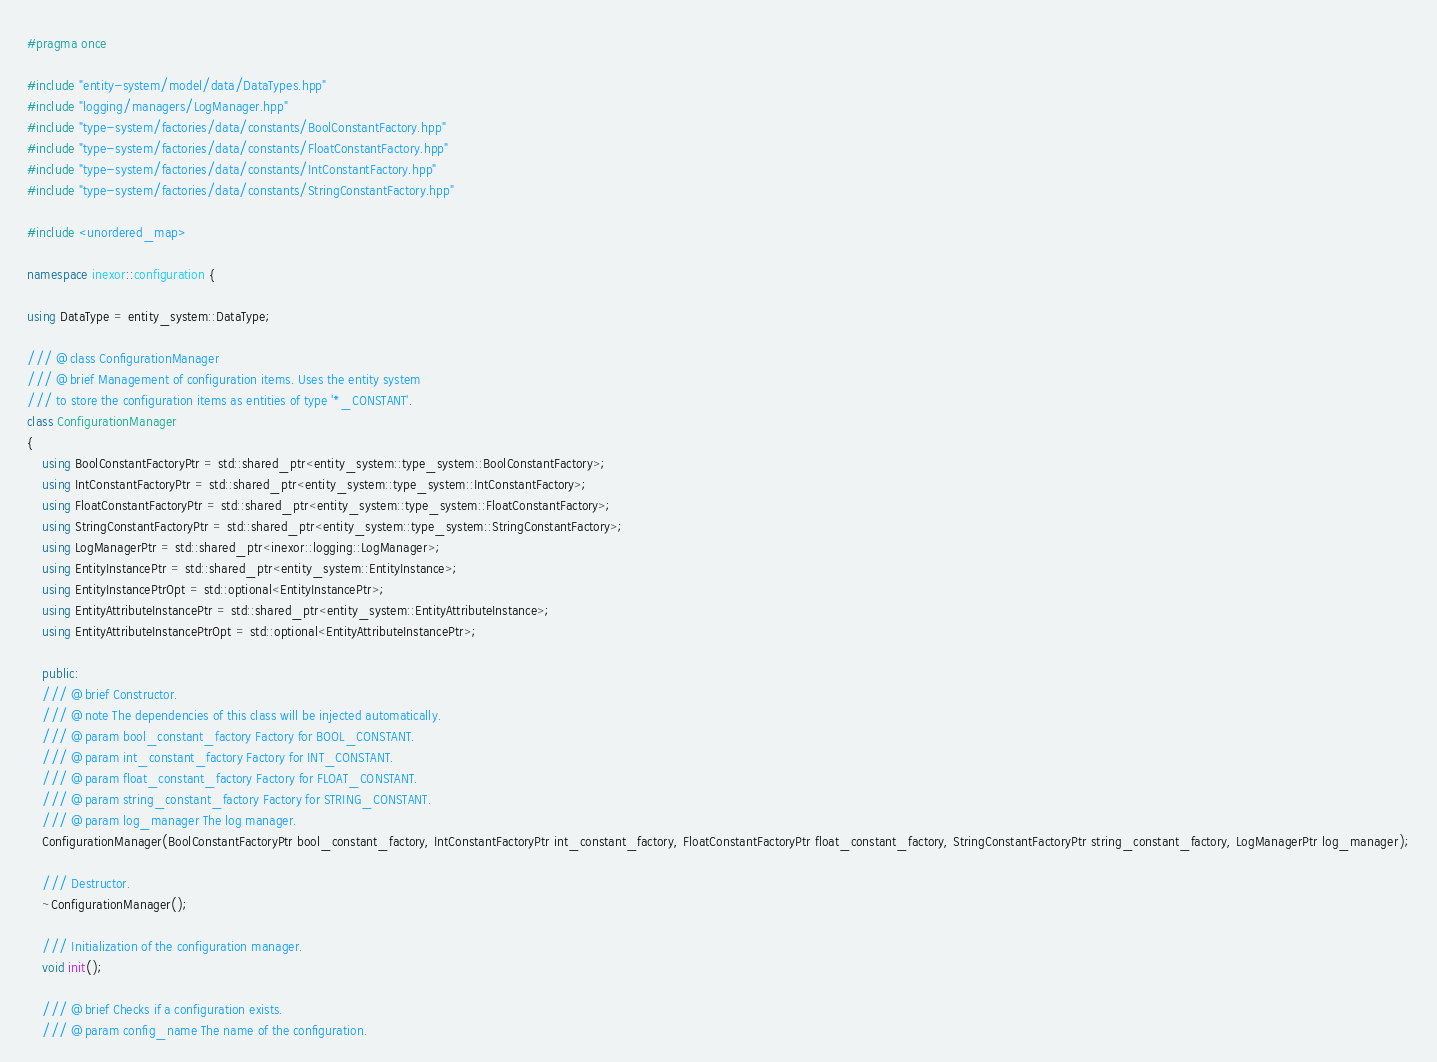<code> <loc_0><loc_0><loc_500><loc_500><_C++_>#pragma once

#include "entity-system/model/data/DataTypes.hpp"
#include "logging/managers/LogManager.hpp"
#include "type-system/factories/data/constants/BoolConstantFactory.hpp"
#include "type-system/factories/data/constants/FloatConstantFactory.hpp"
#include "type-system/factories/data/constants/IntConstantFactory.hpp"
#include "type-system/factories/data/constants/StringConstantFactory.hpp"

#include <unordered_map>

namespace inexor::configuration {

using DataType = entity_system::DataType;

/// @class ConfigurationManager
/// @brief Management of configuration items. Uses the entity system
/// to store the configuration items as entities of type '*_CONSTANT'.
class ConfigurationManager
{
    using BoolConstantFactoryPtr = std::shared_ptr<entity_system::type_system::BoolConstantFactory>;
    using IntConstantFactoryPtr = std::shared_ptr<entity_system::type_system::IntConstantFactory>;
    using FloatConstantFactoryPtr = std::shared_ptr<entity_system::type_system::FloatConstantFactory>;
    using StringConstantFactoryPtr = std::shared_ptr<entity_system::type_system::StringConstantFactory>;
    using LogManagerPtr = std::shared_ptr<inexor::logging::LogManager>;
    using EntityInstancePtr = std::shared_ptr<entity_system::EntityInstance>;
    using EntityInstancePtrOpt = std::optional<EntityInstancePtr>;
    using EntityAttributeInstancePtr = std::shared_ptr<entity_system::EntityAttributeInstance>;
    using EntityAttributeInstancePtrOpt = std::optional<EntityAttributeInstancePtr>;

    public:
    /// @brief Constructor.
    /// @note The dependencies of this class will be injected automatically.
    /// @param bool_constant_factory Factory for BOOL_CONSTANT.
    /// @param int_constant_factory Factory for INT_CONSTANT.
    /// @param float_constant_factory Factory for FLOAT_CONSTANT.
    /// @param string_constant_factory Factory for STRING_CONSTANT.
    /// @param log_manager The log manager.
    ConfigurationManager(BoolConstantFactoryPtr bool_constant_factory, IntConstantFactoryPtr int_constant_factory, FloatConstantFactoryPtr float_constant_factory, StringConstantFactoryPtr string_constant_factory, LogManagerPtr log_manager);

    /// Destructor.
    ~ConfigurationManager();

    /// Initialization of the configuration manager.
    void init();

    /// @brief Checks if a configuration exists.
    /// @param config_name The name of the configuration.</code> 